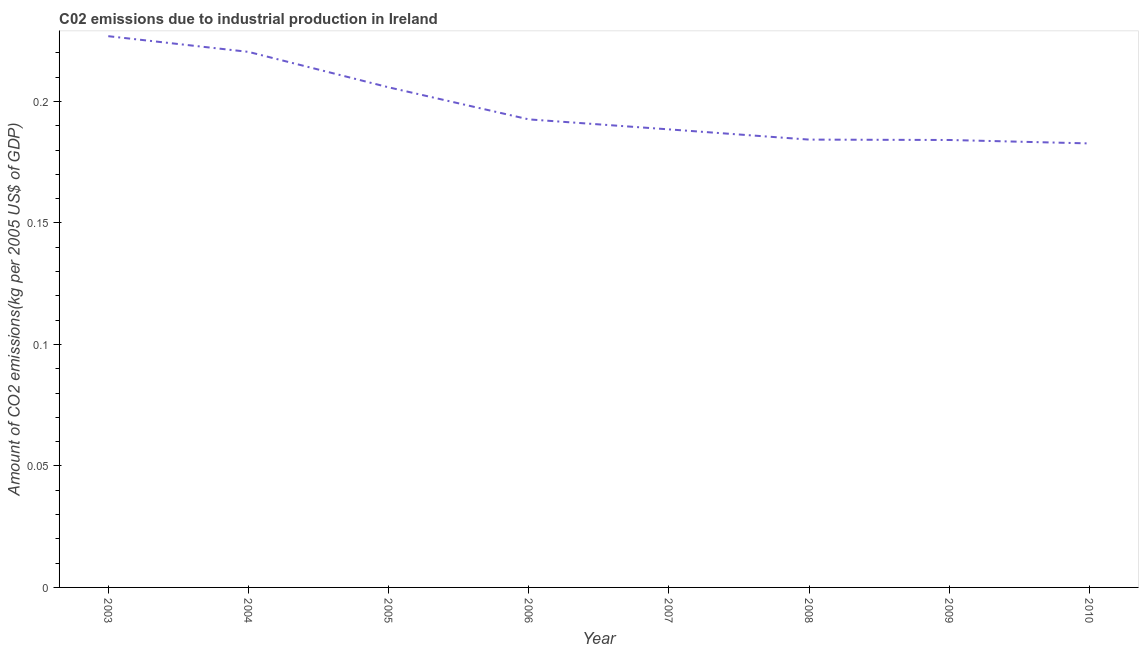What is the amount of co2 emissions in 2004?
Ensure brevity in your answer.  0.22. Across all years, what is the maximum amount of co2 emissions?
Provide a short and direct response. 0.23. Across all years, what is the minimum amount of co2 emissions?
Your answer should be very brief. 0.18. In which year was the amount of co2 emissions maximum?
Give a very brief answer. 2003. What is the sum of the amount of co2 emissions?
Make the answer very short. 1.59. What is the difference between the amount of co2 emissions in 2003 and 2010?
Give a very brief answer. 0.04. What is the average amount of co2 emissions per year?
Keep it short and to the point. 0.2. What is the median amount of co2 emissions?
Make the answer very short. 0.19. What is the ratio of the amount of co2 emissions in 2004 to that in 2008?
Your response must be concise. 1.2. Is the difference between the amount of co2 emissions in 2006 and 2007 greater than the difference between any two years?
Make the answer very short. No. What is the difference between the highest and the second highest amount of co2 emissions?
Your answer should be very brief. 0.01. Is the sum of the amount of co2 emissions in 2003 and 2008 greater than the maximum amount of co2 emissions across all years?
Offer a terse response. Yes. What is the difference between the highest and the lowest amount of co2 emissions?
Offer a very short reply. 0.04. Does the amount of co2 emissions monotonically increase over the years?
Offer a very short reply. No. How many years are there in the graph?
Your answer should be very brief. 8. What is the difference between two consecutive major ticks on the Y-axis?
Your response must be concise. 0.05. Are the values on the major ticks of Y-axis written in scientific E-notation?
Ensure brevity in your answer.  No. Does the graph contain any zero values?
Your answer should be very brief. No. Does the graph contain grids?
Make the answer very short. No. What is the title of the graph?
Make the answer very short. C02 emissions due to industrial production in Ireland. What is the label or title of the X-axis?
Offer a terse response. Year. What is the label or title of the Y-axis?
Your answer should be compact. Amount of CO2 emissions(kg per 2005 US$ of GDP). What is the Amount of CO2 emissions(kg per 2005 US$ of GDP) in 2003?
Offer a very short reply. 0.23. What is the Amount of CO2 emissions(kg per 2005 US$ of GDP) in 2004?
Offer a terse response. 0.22. What is the Amount of CO2 emissions(kg per 2005 US$ of GDP) in 2005?
Offer a terse response. 0.21. What is the Amount of CO2 emissions(kg per 2005 US$ of GDP) of 2006?
Keep it short and to the point. 0.19. What is the Amount of CO2 emissions(kg per 2005 US$ of GDP) in 2007?
Provide a succinct answer. 0.19. What is the Amount of CO2 emissions(kg per 2005 US$ of GDP) of 2008?
Make the answer very short. 0.18. What is the Amount of CO2 emissions(kg per 2005 US$ of GDP) of 2009?
Ensure brevity in your answer.  0.18. What is the Amount of CO2 emissions(kg per 2005 US$ of GDP) of 2010?
Your answer should be very brief. 0.18. What is the difference between the Amount of CO2 emissions(kg per 2005 US$ of GDP) in 2003 and 2004?
Give a very brief answer. 0.01. What is the difference between the Amount of CO2 emissions(kg per 2005 US$ of GDP) in 2003 and 2005?
Offer a terse response. 0.02. What is the difference between the Amount of CO2 emissions(kg per 2005 US$ of GDP) in 2003 and 2006?
Give a very brief answer. 0.03. What is the difference between the Amount of CO2 emissions(kg per 2005 US$ of GDP) in 2003 and 2007?
Offer a very short reply. 0.04. What is the difference between the Amount of CO2 emissions(kg per 2005 US$ of GDP) in 2003 and 2008?
Your answer should be compact. 0.04. What is the difference between the Amount of CO2 emissions(kg per 2005 US$ of GDP) in 2003 and 2009?
Your response must be concise. 0.04. What is the difference between the Amount of CO2 emissions(kg per 2005 US$ of GDP) in 2003 and 2010?
Your answer should be compact. 0.04. What is the difference between the Amount of CO2 emissions(kg per 2005 US$ of GDP) in 2004 and 2005?
Make the answer very short. 0.01. What is the difference between the Amount of CO2 emissions(kg per 2005 US$ of GDP) in 2004 and 2006?
Offer a terse response. 0.03. What is the difference between the Amount of CO2 emissions(kg per 2005 US$ of GDP) in 2004 and 2007?
Your response must be concise. 0.03. What is the difference between the Amount of CO2 emissions(kg per 2005 US$ of GDP) in 2004 and 2008?
Your answer should be very brief. 0.04. What is the difference between the Amount of CO2 emissions(kg per 2005 US$ of GDP) in 2004 and 2009?
Give a very brief answer. 0.04. What is the difference between the Amount of CO2 emissions(kg per 2005 US$ of GDP) in 2004 and 2010?
Offer a terse response. 0.04. What is the difference between the Amount of CO2 emissions(kg per 2005 US$ of GDP) in 2005 and 2006?
Ensure brevity in your answer.  0.01. What is the difference between the Amount of CO2 emissions(kg per 2005 US$ of GDP) in 2005 and 2007?
Offer a terse response. 0.02. What is the difference between the Amount of CO2 emissions(kg per 2005 US$ of GDP) in 2005 and 2008?
Make the answer very short. 0.02. What is the difference between the Amount of CO2 emissions(kg per 2005 US$ of GDP) in 2005 and 2009?
Make the answer very short. 0.02. What is the difference between the Amount of CO2 emissions(kg per 2005 US$ of GDP) in 2005 and 2010?
Your response must be concise. 0.02. What is the difference between the Amount of CO2 emissions(kg per 2005 US$ of GDP) in 2006 and 2007?
Give a very brief answer. 0. What is the difference between the Amount of CO2 emissions(kg per 2005 US$ of GDP) in 2006 and 2008?
Offer a terse response. 0.01. What is the difference between the Amount of CO2 emissions(kg per 2005 US$ of GDP) in 2006 and 2009?
Provide a succinct answer. 0.01. What is the difference between the Amount of CO2 emissions(kg per 2005 US$ of GDP) in 2006 and 2010?
Offer a very short reply. 0.01. What is the difference between the Amount of CO2 emissions(kg per 2005 US$ of GDP) in 2007 and 2008?
Provide a short and direct response. 0. What is the difference between the Amount of CO2 emissions(kg per 2005 US$ of GDP) in 2007 and 2009?
Give a very brief answer. 0. What is the difference between the Amount of CO2 emissions(kg per 2005 US$ of GDP) in 2007 and 2010?
Provide a succinct answer. 0.01. What is the difference between the Amount of CO2 emissions(kg per 2005 US$ of GDP) in 2008 and 2009?
Your answer should be compact. 0. What is the difference between the Amount of CO2 emissions(kg per 2005 US$ of GDP) in 2008 and 2010?
Provide a succinct answer. 0. What is the difference between the Amount of CO2 emissions(kg per 2005 US$ of GDP) in 2009 and 2010?
Your answer should be compact. 0. What is the ratio of the Amount of CO2 emissions(kg per 2005 US$ of GDP) in 2003 to that in 2004?
Give a very brief answer. 1.03. What is the ratio of the Amount of CO2 emissions(kg per 2005 US$ of GDP) in 2003 to that in 2005?
Keep it short and to the point. 1.1. What is the ratio of the Amount of CO2 emissions(kg per 2005 US$ of GDP) in 2003 to that in 2006?
Keep it short and to the point. 1.18. What is the ratio of the Amount of CO2 emissions(kg per 2005 US$ of GDP) in 2003 to that in 2007?
Ensure brevity in your answer.  1.2. What is the ratio of the Amount of CO2 emissions(kg per 2005 US$ of GDP) in 2003 to that in 2008?
Your answer should be compact. 1.23. What is the ratio of the Amount of CO2 emissions(kg per 2005 US$ of GDP) in 2003 to that in 2009?
Your answer should be very brief. 1.23. What is the ratio of the Amount of CO2 emissions(kg per 2005 US$ of GDP) in 2003 to that in 2010?
Your answer should be compact. 1.24. What is the ratio of the Amount of CO2 emissions(kg per 2005 US$ of GDP) in 2004 to that in 2005?
Provide a short and direct response. 1.07. What is the ratio of the Amount of CO2 emissions(kg per 2005 US$ of GDP) in 2004 to that in 2006?
Provide a succinct answer. 1.14. What is the ratio of the Amount of CO2 emissions(kg per 2005 US$ of GDP) in 2004 to that in 2007?
Give a very brief answer. 1.17. What is the ratio of the Amount of CO2 emissions(kg per 2005 US$ of GDP) in 2004 to that in 2008?
Your response must be concise. 1.2. What is the ratio of the Amount of CO2 emissions(kg per 2005 US$ of GDP) in 2004 to that in 2009?
Offer a very short reply. 1.2. What is the ratio of the Amount of CO2 emissions(kg per 2005 US$ of GDP) in 2004 to that in 2010?
Make the answer very short. 1.21. What is the ratio of the Amount of CO2 emissions(kg per 2005 US$ of GDP) in 2005 to that in 2006?
Offer a very short reply. 1.07. What is the ratio of the Amount of CO2 emissions(kg per 2005 US$ of GDP) in 2005 to that in 2007?
Offer a very short reply. 1.09. What is the ratio of the Amount of CO2 emissions(kg per 2005 US$ of GDP) in 2005 to that in 2008?
Offer a very short reply. 1.12. What is the ratio of the Amount of CO2 emissions(kg per 2005 US$ of GDP) in 2005 to that in 2009?
Offer a very short reply. 1.12. What is the ratio of the Amount of CO2 emissions(kg per 2005 US$ of GDP) in 2005 to that in 2010?
Give a very brief answer. 1.13. What is the ratio of the Amount of CO2 emissions(kg per 2005 US$ of GDP) in 2006 to that in 2008?
Your response must be concise. 1.04. What is the ratio of the Amount of CO2 emissions(kg per 2005 US$ of GDP) in 2006 to that in 2009?
Your answer should be compact. 1.05. What is the ratio of the Amount of CO2 emissions(kg per 2005 US$ of GDP) in 2006 to that in 2010?
Offer a very short reply. 1.05. What is the ratio of the Amount of CO2 emissions(kg per 2005 US$ of GDP) in 2007 to that in 2008?
Provide a short and direct response. 1.02. What is the ratio of the Amount of CO2 emissions(kg per 2005 US$ of GDP) in 2007 to that in 2009?
Provide a succinct answer. 1.02. What is the ratio of the Amount of CO2 emissions(kg per 2005 US$ of GDP) in 2007 to that in 2010?
Ensure brevity in your answer.  1.03. What is the ratio of the Amount of CO2 emissions(kg per 2005 US$ of GDP) in 2008 to that in 2009?
Offer a terse response. 1. What is the ratio of the Amount of CO2 emissions(kg per 2005 US$ of GDP) in 2009 to that in 2010?
Your answer should be compact. 1.01. 